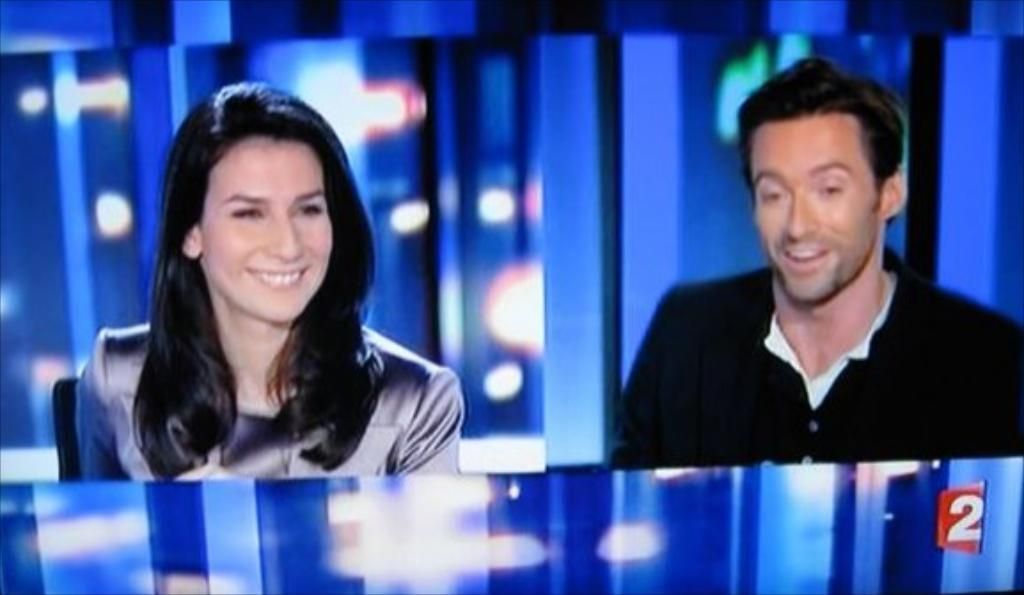What is present in the image that displays visual information? There is a screen in the image. Can you describe the people in the image? There is a man and a woman in the image. What expressions do the man and the woman have? The man and the woman are both smiling. What type of vase can be seen on the screen in the image? There is no vase present on the screen in the image. Is there a cord visible in the image? There is no mention of a cord in the provided facts, so it cannot be determined from the image. 